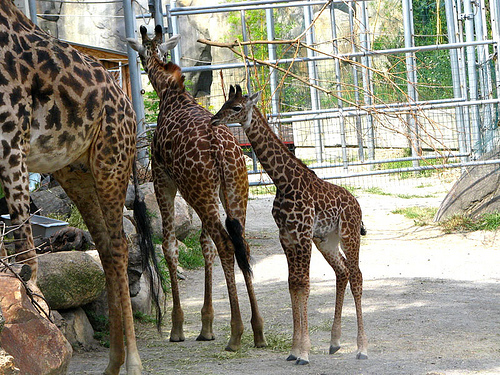How many giraffe heads are visibly looking away from the camera? 1 